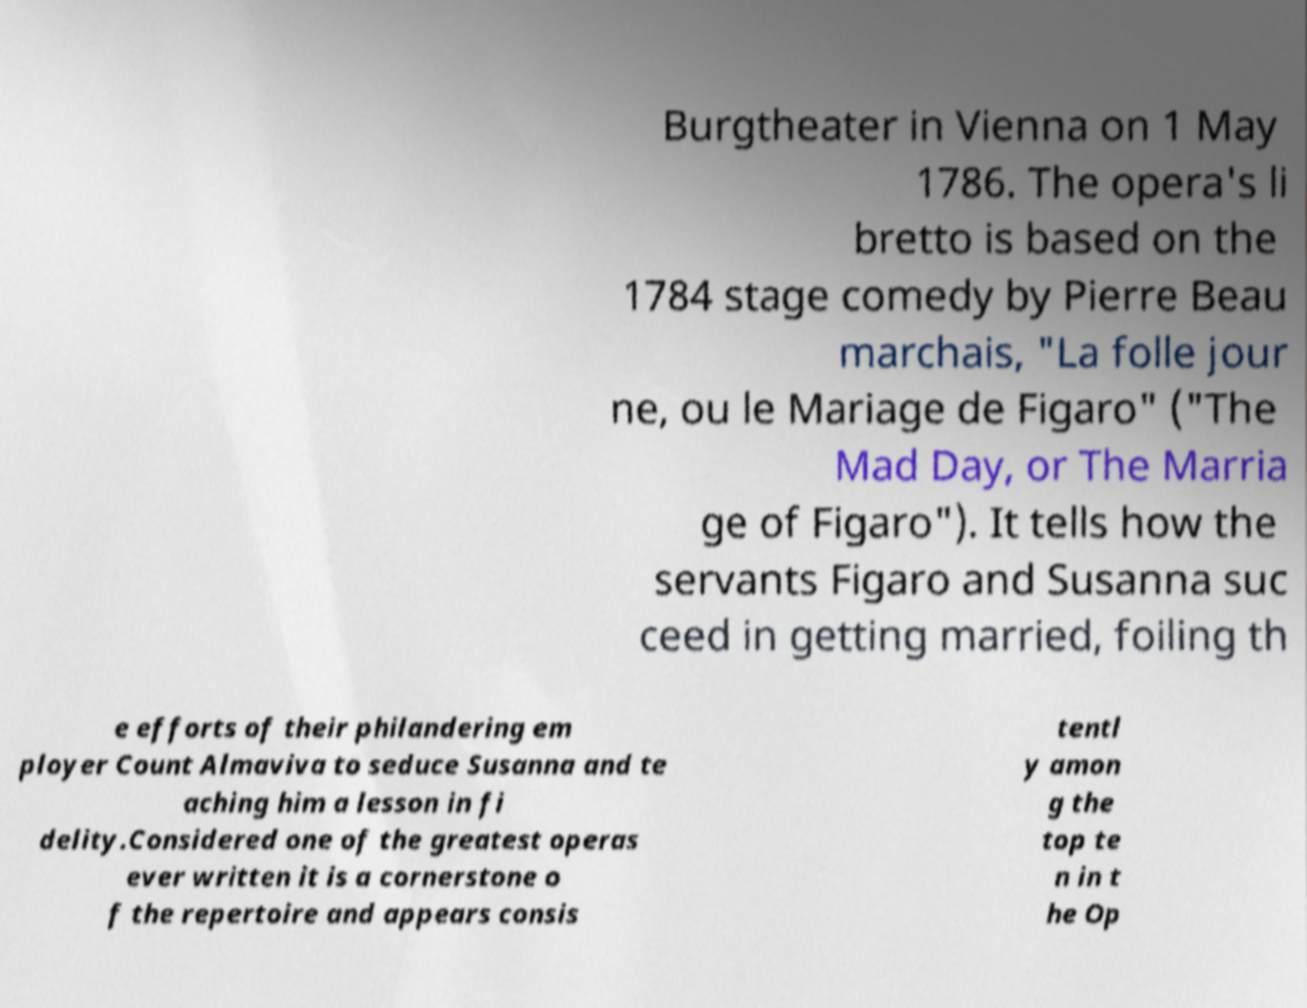Could you assist in decoding the text presented in this image and type it out clearly? Burgtheater in Vienna on 1 May 1786. The opera's li bretto is based on the 1784 stage comedy by Pierre Beau marchais, "La folle jour ne, ou le Mariage de Figaro" ("The Mad Day, or The Marria ge of Figaro"). It tells how the servants Figaro and Susanna suc ceed in getting married, foiling th e efforts of their philandering em ployer Count Almaviva to seduce Susanna and te aching him a lesson in fi delity.Considered one of the greatest operas ever written it is a cornerstone o f the repertoire and appears consis tentl y amon g the top te n in t he Op 